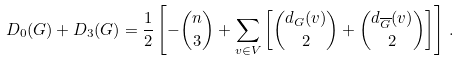Convert formula to latex. <formula><loc_0><loc_0><loc_500><loc_500>D _ { 0 } ( G ) + D _ { 3 } ( G ) = \frac { 1 } { 2 } \left [ - \binom { n } { 3 } + \sum _ { v \in V } \left [ \binom { d _ { G } ( v ) } { 2 } + \binom { d _ { \overline { G } } ( v ) } { 2 } \right ] \right ] \, .</formula> 